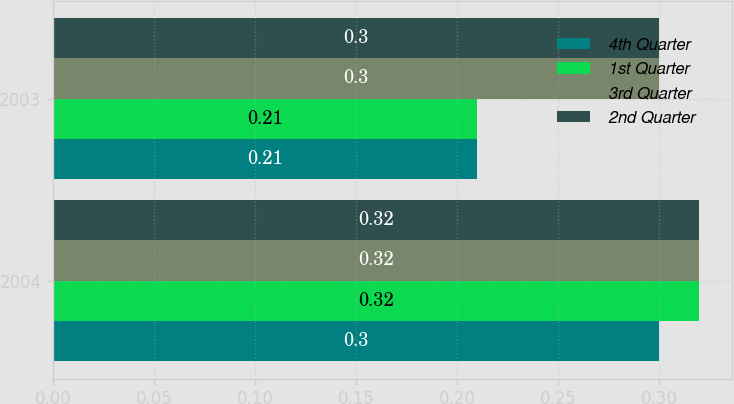<chart> <loc_0><loc_0><loc_500><loc_500><stacked_bar_chart><ecel><fcel>2004<fcel>2003<nl><fcel>4th Quarter<fcel>0.3<fcel>0.21<nl><fcel>1st Quarter<fcel>0.32<fcel>0.21<nl><fcel>3rd Quarter<fcel>0.32<fcel>0.3<nl><fcel>2nd Quarter<fcel>0.32<fcel>0.3<nl></chart> 